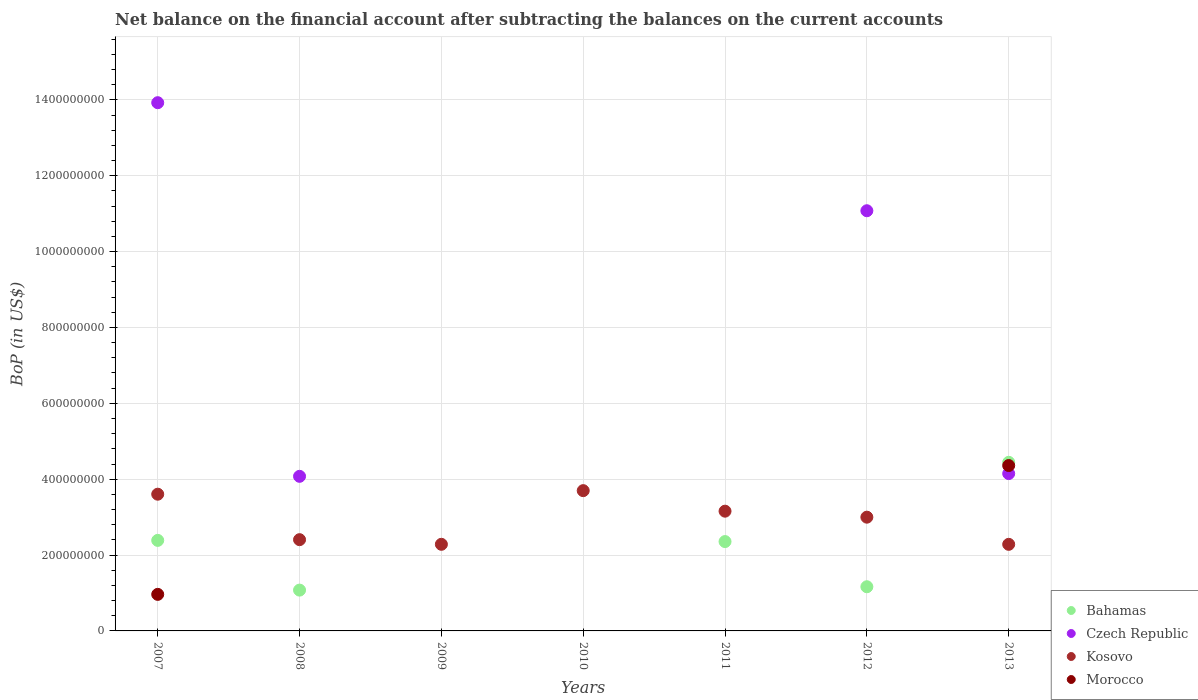Is the number of dotlines equal to the number of legend labels?
Provide a short and direct response. No. Across all years, what is the maximum Balance of Payments in Morocco?
Offer a terse response. 4.36e+08. Across all years, what is the minimum Balance of Payments in Kosovo?
Your answer should be very brief. 2.28e+08. What is the total Balance of Payments in Bahamas in the graph?
Give a very brief answer. 1.14e+09. What is the difference between the Balance of Payments in Czech Republic in 2008 and that in 2012?
Your answer should be very brief. -7.00e+08. What is the difference between the Balance of Payments in Morocco in 2013 and the Balance of Payments in Bahamas in 2012?
Keep it short and to the point. 3.20e+08. What is the average Balance of Payments in Morocco per year?
Make the answer very short. 7.61e+07. In the year 2013, what is the difference between the Balance of Payments in Czech Republic and Balance of Payments in Kosovo?
Your response must be concise. 1.87e+08. In how many years, is the Balance of Payments in Kosovo greater than 1120000000 US$?
Provide a succinct answer. 0. What is the ratio of the Balance of Payments in Kosovo in 2010 to that in 2013?
Offer a terse response. 1.62. Is the Balance of Payments in Kosovo in 2008 less than that in 2011?
Provide a short and direct response. Yes. What is the difference between the highest and the second highest Balance of Payments in Bahamas?
Your answer should be very brief. 2.06e+08. What is the difference between the highest and the lowest Balance of Payments in Bahamas?
Your answer should be very brief. 4.44e+08. In how many years, is the Balance of Payments in Morocco greater than the average Balance of Payments in Morocco taken over all years?
Make the answer very short. 2. Does the Balance of Payments in Bahamas monotonically increase over the years?
Your answer should be very brief. No. Does the graph contain any zero values?
Provide a succinct answer. Yes. Does the graph contain grids?
Offer a very short reply. Yes. Where does the legend appear in the graph?
Give a very brief answer. Bottom right. How are the legend labels stacked?
Provide a short and direct response. Vertical. What is the title of the graph?
Offer a very short reply. Net balance on the financial account after subtracting the balances on the current accounts. What is the label or title of the X-axis?
Provide a succinct answer. Years. What is the label or title of the Y-axis?
Your answer should be compact. BoP (in US$). What is the BoP (in US$) of Bahamas in 2007?
Give a very brief answer. 2.39e+08. What is the BoP (in US$) of Czech Republic in 2007?
Keep it short and to the point. 1.39e+09. What is the BoP (in US$) in Kosovo in 2007?
Your answer should be very brief. 3.60e+08. What is the BoP (in US$) in Morocco in 2007?
Ensure brevity in your answer.  9.64e+07. What is the BoP (in US$) in Bahamas in 2008?
Your response must be concise. 1.08e+08. What is the BoP (in US$) in Czech Republic in 2008?
Offer a very short reply. 4.08e+08. What is the BoP (in US$) in Kosovo in 2008?
Provide a short and direct response. 2.41e+08. What is the BoP (in US$) of Czech Republic in 2009?
Your answer should be very brief. 0. What is the BoP (in US$) in Kosovo in 2009?
Your answer should be very brief. 2.28e+08. What is the BoP (in US$) in Morocco in 2009?
Keep it short and to the point. 0. What is the BoP (in US$) of Bahamas in 2010?
Offer a terse response. 0. What is the BoP (in US$) in Kosovo in 2010?
Provide a short and direct response. 3.70e+08. What is the BoP (in US$) of Bahamas in 2011?
Make the answer very short. 2.36e+08. What is the BoP (in US$) of Czech Republic in 2011?
Make the answer very short. 0. What is the BoP (in US$) of Kosovo in 2011?
Offer a terse response. 3.16e+08. What is the BoP (in US$) of Bahamas in 2012?
Provide a succinct answer. 1.16e+08. What is the BoP (in US$) in Czech Republic in 2012?
Provide a short and direct response. 1.11e+09. What is the BoP (in US$) of Kosovo in 2012?
Ensure brevity in your answer.  3.00e+08. What is the BoP (in US$) of Bahamas in 2013?
Offer a terse response. 4.44e+08. What is the BoP (in US$) of Czech Republic in 2013?
Offer a very short reply. 4.15e+08. What is the BoP (in US$) in Kosovo in 2013?
Keep it short and to the point. 2.28e+08. What is the BoP (in US$) of Morocco in 2013?
Keep it short and to the point. 4.36e+08. Across all years, what is the maximum BoP (in US$) of Bahamas?
Your answer should be compact. 4.44e+08. Across all years, what is the maximum BoP (in US$) of Czech Republic?
Your response must be concise. 1.39e+09. Across all years, what is the maximum BoP (in US$) in Kosovo?
Your answer should be very brief. 3.70e+08. Across all years, what is the maximum BoP (in US$) of Morocco?
Your answer should be very brief. 4.36e+08. Across all years, what is the minimum BoP (in US$) in Czech Republic?
Give a very brief answer. 0. Across all years, what is the minimum BoP (in US$) of Kosovo?
Make the answer very short. 2.28e+08. Across all years, what is the minimum BoP (in US$) of Morocco?
Offer a terse response. 0. What is the total BoP (in US$) of Bahamas in the graph?
Give a very brief answer. 1.14e+09. What is the total BoP (in US$) in Czech Republic in the graph?
Make the answer very short. 3.32e+09. What is the total BoP (in US$) of Kosovo in the graph?
Keep it short and to the point. 2.04e+09. What is the total BoP (in US$) in Morocco in the graph?
Your answer should be very brief. 5.32e+08. What is the difference between the BoP (in US$) in Bahamas in 2007 and that in 2008?
Offer a terse response. 1.31e+08. What is the difference between the BoP (in US$) of Czech Republic in 2007 and that in 2008?
Give a very brief answer. 9.85e+08. What is the difference between the BoP (in US$) of Kosovo in 2007 and that in 2008?
Offer a very short reply. 1.20e+08. What is the difference between the BoP (in US$) in Kosovo in 2007 and that in 2009?
Your answer should be very brief. 1.32e+08. What is the difference between the BoP (in US$) in Kosovo in 2007 and that in 2010?
Offer a terse response. -9.38e+06. What is the difference between the BoP (in US$) in Bahamas in 2007 and that in 2011?
Offer a very short reply. 3.11e+06. What is the difference between the BoP (in US$) of Kosovo in 2007 and that in 2011?
Provide a succinct answer. 4.47e+07. What is the difference between the BoP (in US$) of Bahamas in 2007 and that in 2012?
Ensure brevity in your answer.  1.22e+08. What is the difference between the BoP (in US$) of Czech Republic in 2007 and that in 2012?
Your response must be concise. 2.85e+08. What is the difference between the BoP (in US$) in Kosovo in 2007 and that in 2012?
Provide a short and direct response. 6.06e+07. What is the difference between the BoP (in US$) in Bahamas in 2007 and that in 2013?
Your answer should be compact. -2.06e+08. What is the difference between the BoP (in US$) in Czech Republic in 2007 and that in 2013?
Make the answer very short. 9.78e+08. What is the difference between the BoP (in US$) of Kosovo in 2007 and that in 2013?
Offer a terse response. 1.32e+08. What is the difference between the BoP (in US$) of Morocco in 2007 and that in 2013?
Give a very brief answer. -3.40e+08. What is the difference between the BoP (in US$) in Kosovo in 2008 and that in 2009?
Your response must be concise. 1.22e+07. What is the difference between the BoP (in US$) in Kosovo in 2008 and that in 2010?
Provide a succinct answer. -1.29e+08. What is the difference between the BoP (in US$) in Bahamas in 2008 and that in 2011?
Make the answer very short. -1.28e+08. What is the difference between the BoP (in US$) in Kosovo in 2008 and that in 2011?
Give a very brief answer. -7.51e+07. What is the difference between the BoP (in US$) of Bahamas in 2008 and that in 2012?
Give a very brief answer. -8.90e+06. What is the difference between the BoP (in US$) in Czech Republic in 2008 and that in 2012?
Give a very brief answer. -7.00e+08. What is the difference between the BoP (in US$) in Kosovo in 2008 and that in 2012?
Give a very brief answer. -5.93e+07. What is the difference between the BoP (in US$) of Bahamas in 2008 and that in 2013?
Your response must be concise. -3.37e+08. What is the difference between the BoP (in US$) of Czech Republic in 2008 and that in 2013?
Provide a succinct answer. -7.21e+06. What is the difference between the BoP (in US$) in Kosovo in 2008 and that in 2013?
Your answer should be compact. 1.23e+07. What is the difference between the BoP (in US$) in Kosovo in 2009 and that in 2010?
Give a very brief answer. -1.41e+08. What is the difference between the BoP (in US$) of Kosovo in 2009 and that in 2011?
Ensure brevity in your answer.  -8.73e+07. What is the difference between the BoP (in US$) of Kosovo in 2009 and that in 2012?
Offer a terse response. -7.15e+07. What is the difference between the BoP (in US$) of Kosovo in 2009 and that in 2013?
Keep it short and to the point. 7.20e+04. What is the difference between the BoP (in US$) in Kosovo in 2010 and that in 2011?
Your answer should be compact. 5.41e+07. What is the difference between the BoP (in US$) of Kosovo in 2010 and that in 2012?
Your answer should be compact. 6.99e+07. What is the difference between the BoP (in US$) in Kosovo in 2010 and that in 2013?
Your answer should be compact. 1.42e+08. What is the difference between the BoP (in US$) of Bahamas in 2011 and that in 2012?
Offer a terse response. 1.19e+08. What is the difference between the BoP (in US$) in Kosovo in 2011 and that in 2012?
Give a very brief answer. 1.58e+07. What is the difference between the BoP (in US$) of Bahamas in 2011 and that in 2013?
Provide a succinct answer. -2.09e+08. What is the difference between the BoP (in US$) in Kosovo in 2011 and that in 2013?
Your answer should be compact. 8.74e+07. What is the difference between the BoP (in US$) of Bahamas in 2012 and that in 2013?
Give a very brief answer. -3.28e+08. What is the difference between the BoP (in US$) in Czech Republic in 2012 and that in 2013?
Give a very brief answer. 6.93e+08. What is the difference between the BoP (in US$) of Kosovo in 2012 and that in 2013?
Make the answer very short. 7.16e+07. What is the difference between the BoP (in US$) in Bahamas in 2007 and the BoP (in US$) in Czech Republic in 2008?
Offer a very short reply. -1.69e+08. What is the difference between the BoP (in US$) of Bahamas in 2007 and the BoP (in US$) of Kosovo in 2008?
Make the answer very short. -1.89e+06. What is the difference between the BoP (in US$) in Czech Republic in 2007 and the BoP (in US$) in Kosovo in 2008?
Your answer should be compact. 1.15e+09. What is the difference between the BoP (in US$) of Bahamas in 2007 and the BoP (in US$) of Kosovo in 2009?
Make the answer very short. 1.03e+07. What is the difference between the BoP (in US$) of Czech Republic in 2007 and the BoP (in US$) of Kosovo in 2009?
Your answer should be compact. 1.16e+09. What is the difference between the BoP (in US$) in Bahamas in 2007 and the BoP (in US$) in Kosovo in 2010?
Keep it short and to the point. -1.31e+08. What is the difference between the BoP (in US$) of Czech Republic in 2007 and the BoP (in US$) of Kosovo in 2010?
Your response must be concise. 1.02e+09. What is the difference between the BoP (in US$) of Bahamas in 2007 and the BoP (in US$) of Kosovo in 2011?
Offer a terse response. -7.70e+07. What is the difference between the BoP (in US$) in Czech Republic in 2007 and the BoP (in US$) in Kosovo in 2011?
Your response must be concise. 1.08e+09. What is the difference between the BoP (in US$) of Bahamas in 2007 and the BoP (in US$) of Czech Republic in 2012?
Give a very brief answer. -8.69e+08. What is the difference between the BoP (in US$) in Bahamas in 2007 and the BoP (in US$) in Kosovo in 2012?
Your answer should be compact. -6.12e+07. What is the difference between the BoP (in US$) of Czech Republic in 2007 and the BoP (in US$) of Kosovo in 2012?
Offer a very short reply. 1.09e+09. What is the difference between the BoP (in US$) of Bahamas in 2007 and the BoP (in US$) of Czech Republic in 2013?
Give a very brief answer. -1.76e+08. What is the difference between the BoP (in US$) of Bahamas in 2007 and the BoP (in US$) of Kosovo in 2013?
Give a very brief answer. 1.04e+07. What is the difference between the BoP (in US$) in Bahamas in 2007 and the BoP (in US$) in Morocco in 2013?
Your answer should be compact. -1.97e+08. What is the difference between the BoP (in US$) in Czech Republic in 2007 and the BoP (in US$) in Kosovo in 2013?
Ensure brevity in your answer.  1.16e+09. What is the difference between the BoP (in US$) in Czech Republic in 2007 and the BoP (in US$) in Morocco in 2013?
Provide a succinct answer. 9.57e+08. What is the difference between the BoP (in US$) of Kosovo in 2007 and the BoP (in US$) of Morocco in 2013?
Your answer should be very brief. -7.56e+07. What is the difference between the BoP (in US$) of Bahamas in 2008 and the BoP (in US$) of Kosovo in 2009?
Your answer should be very brief. -1.21e+08. What is the difference between the BoP (in US$) in Czech Republic in 2008 and the BoP (in US$) in Kosovo in 2009?
Make the answer very short. 1.79e+08. What is the difference between the BoP (in US$) in Bahamas in 2008 and the BoP (in US$) in Kosovo in 2010?
Keep it short and to the point. -2.62e+08. What is the difference between the BoP (in US$) in Czech Republic in 2008 and the BoP (in US$) in Kosovo in 2010?
Keep it short and to the point. 3.78e+07. What is the difference between the BoP (in US$) in Bahamas in 2008 and the BoP (in US$) in Kosovo in 2011?
Ensure brevity in your answer.  -2.08e+08. What is the difference between the BoP (in US$) of Czech Republic in 2008 and the BoP (in US$) of Kosovo in 2011?
Give a very brief answer. 9.19e+07. What is the difference between the BoP (in US$) of Bahamas in 2008 and the BoP (in US$) of Czech Republic in 2012?
Offer a very short reply. -1.00e+09. What is the difference between the BoP (in US$) of Bahamas in 2008 and the BoP (in US$) of Kosovo in 2012?
Your response must be concise. -1.92e+08. What is the difference between the BoP (in US$) of Czech Republic in 2008 and the BoP (in US$) of Kosovo in 2012?
Your answer should be compact. 1.08e+08. What is the difference between the BoP (in US$) in Bahamas in 2008 and the BoP (in US$) in Czech Republic in 2013?
Offer a terse response. -3.07e+08. What is the difference between the BoP (in US$) of Bahamas in 2008 and the BoP (in US$) of Kosovo in 2013?
Provide a succinct answer. -1.21e+08. What is the difference between the BoP (in US$) in Bahamas in 2008 and the BoP (in US$) in Morocco in 2013?
Your answer should be very brief. -3.28e+08. What is the difference between the BoP (in US$) in Czech Republic in 2008 and the BoP (in US$) in Kosovo in 2013?
Your response must be concise. 1.79e+08. What is the difference between the BoP (in US$) of Czech Republic in 2008 and the BoP (in US$) of Morocco in 2013?
Keep it short and to the point. -2.84e+07. What is the difference between the BoP (in US$) of Kosovo in 2008 and the BoP (in US$) of Morocco in 2013?
Your answer should be compact. -1.95e+08. What is the difference between the BoP (in US$) of Kosovo in 2009 and the BoP (in US$) of Morocco in 2013?
Your answer should be compact. -2.08e+08. What is the difference between the BoP (in US$) in Kosovo in 2010 and the BoP (in US$) in Morocco in 2013?
Provide a succinct answer. -6.62e+07. What is the difference between the BoP (in US$) in Bahamas in 2011 and the BoP (in US$) in Czech Republic in 2012?
Your answer should be very brief. -8.72e+08. What is the difference between the BoP (in US$) in Bahamas in 2011 and the BoP (in US$) in Kosovo in 2012?
Your response must be concise. -6.43e+07. What is the difference between the BoP (in US$) of Bahamas in 2011 and the BoP (in US$) of Czech Republic in 2013?
Provide a short and direct response. -1.79e+08. What is the difference between the BoP (in US$) in Bahamas in 2011 and the BoP (in US$) in Kosovo in 2013?
Provide a short and direct response. 7.30e+06. What is the difference between the BoP (in US$) of Bahamas in 2011 and the BoP (in US$) of Morocco in 2013?
Your answer should be very brief. -2.00e+08. What is the difference between the BoP (in US$) of Kosovo in 2011 and the BoP (in US$) of Morocco in 2013?
Your answer should be compact. -1.20e+08. What is the difference between the BoP (in US$) in Bahamas in 2012 and the BoP (in US$) in Czech Republic in 2013?
Keep it short and to the point. -2.98e+08. What is the difference between the BoP (in US$) in Bahamas in 2012 and the BoP (in US$) in Kosovo in 2013?
Your answer should be very brief. -1.12e+08. What is the difference between the BoP (in US$) in Bahamas in 2012 and the BoP (in US$) in Morocco in 2013?
Your answer should be very brief. -3.20e+08. What is the difference between the BoP (in US$) of Czech Republic in 2012 and the BoP (in US$) of Kosovo in 2013?
Provide a succinct answer. 8.79e+08. What is the difference between the BoP (in US$) of Czech Republic in 2012 and the BoP (in US$) of Morocco in 2013?
Ensure brevity in your answer.  6.72e+08. What is the difference between the BoP (in US$) in Kosovo in 2012 and the BoP (in US$) in Morocco in 2013?
Offer a very short reply. -1.36e+08. What is the average BoP (in US$) of Bahamas per year?
Provide a short and direct response. 1.63e+08. What is the average BoP (in US$) in Czech Republic per year?
Provide a succinct answer. 4.75e+08. What is the average BoP (in US$) in Kosovo per year?
Your answer should be compact. 2.92e+08. What is the average BoP (in US$) in Morocco per year?
Offer a terse response. 7.61e+07. In the year 2007, what is the difference between the BoP (in US$) of Bahamas and BoP (in US$) of Czech Republic?
Make the answer very short. -1.15e+09. In the year 2007, what is the difference between the BoP (in US$) in Bahamas and BoP (in US$) in Kosovo?
Offer a terse response. -1.22e+08. In the year 2007, what is the difference between the BoP (in US$) in Bahamas and BoP (in US$) in Morocco?
Provide a succinct answer. 1.42e+08. In the year 2007, what is the difference between the BoP (in US$) in Czech Republic and BoP (in US$) in Kosovo?
Offer a terse response. 1.03e+09. In the year 2007, what is the difference between the BoP (in US$) in Czech Republic and BoP (in US$) in Morocco?
Offer a very short reply. 1.30e+09. In the year 2007, what is the difference between the BoP (in US$) in Kosovo and BoP (in US$) in Morocco?
Your answer should be very brief. 2.64e+08. In the year 2008, what is the difference between the BoP (in US$) in Bahamas and BoP (in US$) in Czech Republic?
Offer a very short reply. -3.00e+08. In the year 2008, what is the difference between the BoP (in US$) of Bahamas and BoP (in US$) of Kosovo?
Your answer should be very brief. -1.33e+08. In the year 2008, what is the difference between the BoP (in US$) in Czech Republic and BoP (in US$) in Kosovo?
Keep it short and to the point. 1.67e+08. In the year 2011, what is the difference between the BoP (in US$) of Bahamas and BoP (in US$) of Kosovo?
Make the answer very short. -8.01e+07. In the year 2012, what is the difference between the BoP (in US$) of Bahamas and BoP (in US$) of Czech Republic?
Make the answer very short. -9.91e+08. In the year 2012, what is the difference between the BoP (in US$) of Bahamas and BoP (in US$) of Kosovo?
Ensure brevity in your answer.  -1.83e+08. In the year 2012, what is the difference between the BoP (in US$) of Czech Republic and BoP (in US$) of Kosovo?
Your answer should be very brief. 8.08e+08. In the year 2013, what is the difference between the BoP (in US$) in Bahamas and BoP (in US$) in Czech Republic?
Make the answer very short. 2.97e+07. In the year 2013, what is the difference between the BoP (in US$) of Bahamas and BoP (in US$) of Kosovo?
Your answer should be compact. 2.16e+08. In the year 2013, what is the difference between the BoP (in US$) of Bahamas and BoP (in US$) of Morocco?
Give a very brief answer. 8.49e+06. In the year 2013, what is the difference between the BoP (in US$) of Czech Republic and BoP (in US$) of Kosovo?
Ensure brevity in your answer.  1.87e+08. In the year 2013, what is the difference between the BoP (in US$) in Czech Republic and BoP (in US$) in Morocco?
Offer a terse response. -2.12e+07. In the year 2013, what is the difference between the BoP (in US$) in Kosovo and BoP (in US$) in Morocco?
Give a very brief answer. -2.08e+08. What is the ratio of the BoP (in US$) in Bahamas in 2007 to that in 2008?
Your answer should be very brief. 2.22. What is the ratio of the BoP (in US$) of Czech Republic in 2007 to that in 2008?
Provide a succinct answer. 3.42. What is the ratio of the BoP (in US$) in Kosovo in 2007 to that in 2008?
Your answer should be compact. 1.5. What is the ratio of the BoP (in US$) of Kosovo in 2007 to that in 2009?
Make the answer very short. 1.58. What is the ratio of the BoP (in US$) of Kosovo in 2007 to that in 2010?
Keep it short and to the point. 0.97. What is the ratio of the BoP (in US$) of Bahamas in 2007 to that in 2011?
Offer a very short reply. 1.01. What is the ratio of the BoP (in US$) in Kosovo in 2007 to that in 2011?
Provide a succinct answer. 1.14. What is the ratio of the BoP (in US$) in Bahamas in 2007 to that in 2012?
Your answer should be compact. 2.05. What is the ratio of the BoP (in US$) in Czech Republic in 2007 to that in 2012?
Offer a very short reply. 1.26. What is the ratio of the BoP (in US$) of Kosovo in 2007 to that in 2012?
Keep it short and to the point. 1.2. What is the ratio of the BoP (in US$) in Bahamas in 2007 to that in 2013?
Offer a terse response. 0.54. What is the ratio of the BoP (in US$) in Czech Republic in 2007 to that in 2013?
Provide a succinct answer. 3.36. What is the ratio of the BoP (in US$) of Kosovo in 2007 to that in 2013?
Ensure brevity in your answer.  1.58. What is the ratio of the BoP (in US$) of Morocco in 2007 to that in 2013?
Your answer should be compact. 0.22. What is the ratio of the BoP (in US$) of Kosovo in 2008 to that in 2009?
Make the answer very short. 1.05. What is the ratio of the BoP (in US$) in Kosovo in 2008 to that in 2010?
Offer a terse response. 0.65. What is the ratio of the BoP (in US$) in Bahamas in 2008 to that in 2011?
Give a very brief answer. 0.46. What is the ratio of the BoP (in US$) in Kosovo in 2008 to that in 2011?
Offer a very short reply. 0.76. What is the ratio of the BoP (in US$) in Bahamas in 2008 to that in 2012?
Provide a succinct answer. 0.92. What is the ratio of the BoP (in US$) of Czech Republic in 2008 to that in 2012?
Provide a short and direct response. 0.37. What is the ratio of the BoP (in US$) in Kosovo in 2008 to that in 2012?
Keep it short and to the point. 0.8. What is the ratio of the BoP (in US$) in Bahamas in 2008 to that in 2013?
Make the answer very short. 0.24. What is the ratio of the BoP (in US$) of Czech Republic in 2008 to that in 2013?
Your answer should be compact. 0.98. What is the ratio of the BoP (in US$) in Kosovo in 2008 to that in 2013?
Make the answer very short. 1.05. What is the ratio of the BoP (in US$) in Kosovo in 2009 to that in 2010?
Your response must be concise. 0.62. What is the ratio of the BoP (in US$) in Kosovo in 2009 to that in 2011?
Offer a terse response. 0.72. What is the ratio of the BoP (in US$) in Kosovo in 2009 to that in 2012?
Your answer should be very brief. 0.76. What is the ratio of the BoP (in US$) of Kosovo in 2010 to that in 2011?
Offer a very short reply. 1.17. What is the ratio of the BoP (in US$) of Kosovo in 2010 to that in 2012?
Offer a very short reply. 1.23. What is the ratio of the BoP (in US$) in Kosovo in 2010 to that in 2013?
Provide a succinct answer. 1.62. What is the ratio of the BoP (in US$) of Bahamas in 2011 to that in 2012?
Provide a short and direct response. 2.02. What is the ratio of the BoP (in US$) of Kosovo in 2011 to that in 2012?
Your answer should be compact. 1.05. What is the ratio of the BoP (in US$) of Bahamas in 2011 to that in 2013?
Give a very brief answer. 0.53. What is the ratio of the BoP (in US$) in Kosovo in 2011 to that in 2013?
Ensure brevity in your answer.  1.38. What is the ratio of the BoP (in US$) in Bahamas in 2012 to that in 2013?
Ensure brevity in your answer.  0.26. What is the ratio of the BoP (in US$) of Czech Republic in 2012 to that in 2013?
Your answer should be compact. 2.67. What is the ratio of the BoP (in US$) in Kosovo in 2012 to that in 2013?
Make the answer very short. 1.31. What is the difference between the highest and the second highest BoP (in US$) in Bahamas?
Offer a very short reply. 2.06e+08. What is the difference between the highest and the second highest BoP (in US$) of Czech Republic?
Keep it short and to the point. 2.85e+08. What is the difference between the highest and the second highest BoP (in US$) in Kosovo?
Your response must be concise. 9.38e+06. What is the difference between the highest and the lowest BoP (in US$) in Bahamas?
Offer a very short reply. 4.44e+08. What is the difference between the highest and the lowest BoP (in US$) in Czech Republic?
Your response must be concise. 1.39e+09. What is the difference between the highest and the lowest BoP (in US$) in Kosovo?
Make the answer very short. 1.42e+08. What is the difference between the highest and the lowest BoP (in US$) in Morocco?
Your answer should be very brief. 4.36e+08. 